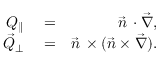<formula> <loc_0><loc_0><loc_500><loc_500>\begin{array} { r l r } { Q _ { \| } } & = } & { \vec { n } \, \cdot \vec { \nabla } , } \\ { \vec { Q } _ { \perp } } & = } & { \vec { n } \, \times ( \vec { n } \times \vec { \nabla } ) . } \end{array}</formula> 